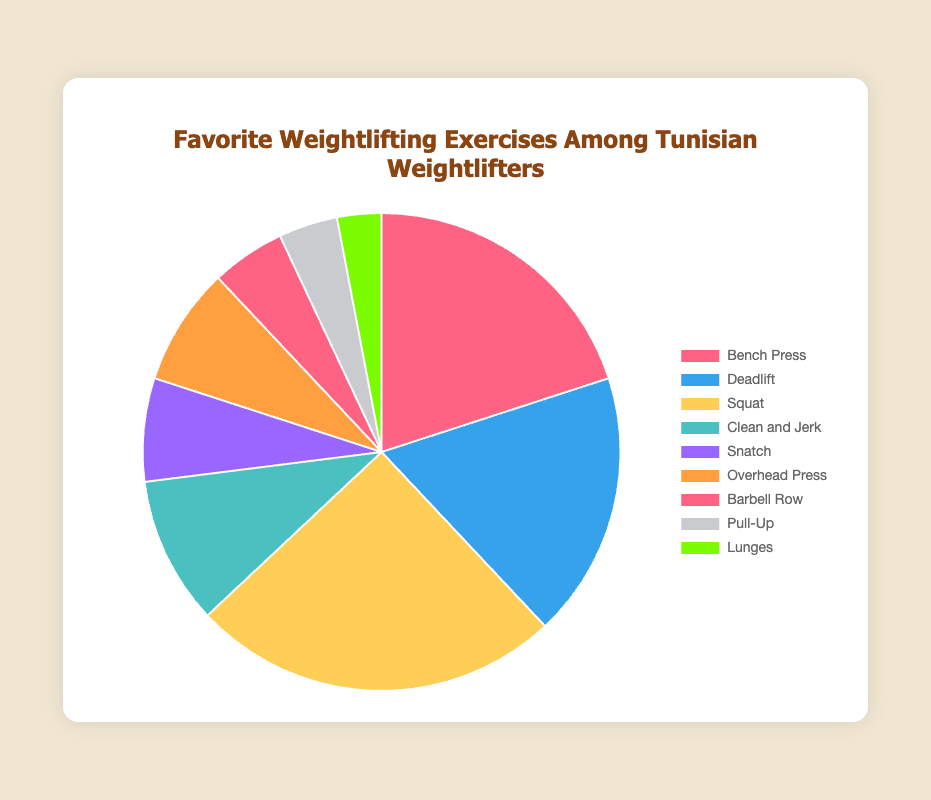What is the most popular weightlifting exercise among Tunisian weightlifters? The most popular exercise can be identified by looking at the section of the pie chart with the largest percentage. In this case, it is Squat with 25%.
Answer: Squat What is the percentage difference between Bench Press and Deadlift? First, note the percentage for Bench Press (20%) and Deadlift (18%). Subtract the smaller percentage from the larger percentage: 20% - 18% = 2%.
Answer: 2% Which exercises combined make up 50% of the preferences? Adding the percentages from the highest down until the sum reaches 50%: Squat (25%) + Bench Press (20%) + Deadlift (18%). These sum to 63%, exceeding half. Thus, ignoring Deadlift, Squat + Bench Press = 45%, and the next highest is Clean and Jerk at 10%, which when combined with Squat and Bench Press gives more than 50%.
Answer: Squat, Bench Press, and Deadlift How many exercises have less than 10% preference? Observe the sections of the pie chart with percentages less than 10%. These exercises are Snatch (7%), Overhead Press (8%), Barbell Row (5%), Pull-Up (4%), and Lunges (3%), totaling 5 exercises.
Answer: 5 Is the combined preference for Pull-Up and Lunges greater than that for Bench Press? Add the percentages for Pull-Up (4%) and Lunges (3%) which equals 7%. Compare this with Bench Press (20%). 7% is less than 20%.
Answer: No What is the combined percentage for all exercises other than Squat? First, note the percentage for Squat (25%). Subtract this from 100% to find the combined percentage of all other exercises: 100% - 25% = 75%.
Answer: 75% Which exercise corresponding to the green segment has what percentage? Identify the green section in the pie chart. The green segment corresponds to Lunges with 3%.
Answer: Lunges Compare the preference for Overhead Press to Barbell Row. Which one is more preferred and by how much? Note the percentages for Overhead Press (8%) and Barbell Row (5%). Subtract the smaller from the larger: 8% - 5% = 3%. Overhead Press is more preferred.
Answer: Overhead Press by 3% What is the total percentage for the top three weightlifting exercises? Add the percentages for the top three exercises: Squat (25%) + Bench Press (20%) + Deadlift (18%). This equals 63%.
Answer: 63% What percentage of preferences are accounted for by exercises other than the least popular one? Identify the percentage for the least popular exercise, Lunges (3%). Subtract this from 100% to find the percentage for all other exercises: 100% - 3% = 97%.
Answer: 97% 